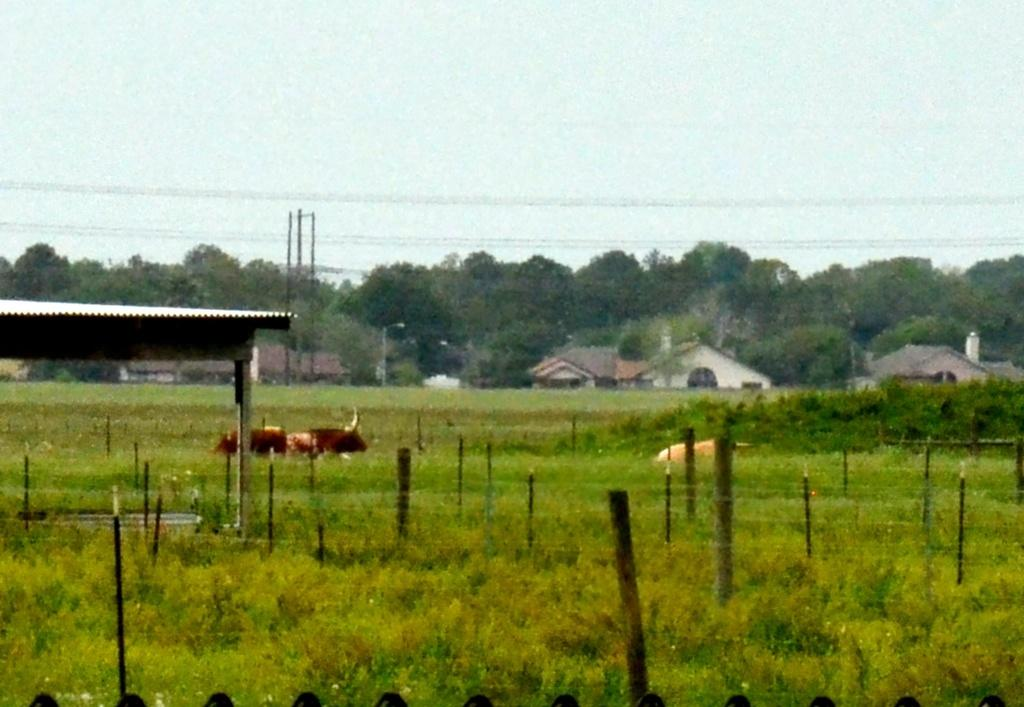What type of structure can be seen in the image? There is a shed in the image. What other buildings are present in the image? There are houses in the image. What material is used to make the wooden sticks in the image? The wooden sticks in the image are made of wood. What type of vegetation is present in the image? There is grass and trees in the image. What can be seen in the background of the image? The sky is visible in the background of the image. Can you tell me how many snails are crawling on the wooden sticks in the image? There are no snails present in the image; it only features a shed, houses, wooden sticks, grass, trees, and the sky. What is the afterthought of the person who built the shed in the image? The image does not provide any information about the person who built the shed or their thoughts or intentions. 